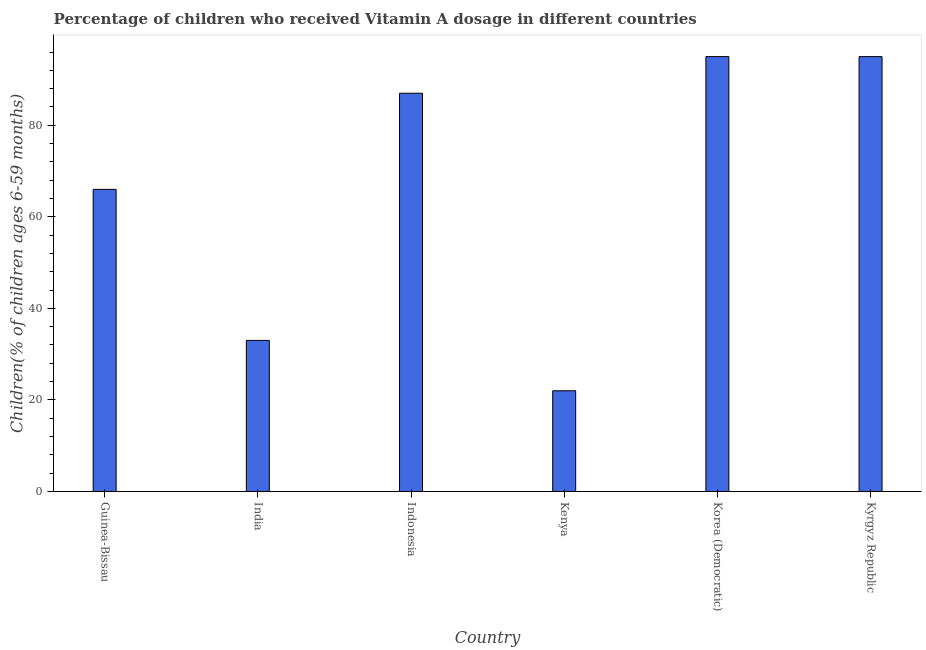Does the graph contain any zero values?
Your response must be concise. No. What is the title of the graph?
Your response must be concise. Percentage of children who received Vitamin A dosage in different countries. What is the label or title of the X-axis?
Offer a very short reply. Country. What is the label or title of the Y-axis?
Your answer should be compact. Children(% of children ages 6-59 months). What is the vitamin a supplementation coverage rate in Guinea-Bissau?
Offer a terse response. 66. Across all countries, what is the minimum vitamin a supplementation coverage rate?
Provide a succinct answer. 22. In which country was the vitamin a supplementation coverage rate maximum?
Your answer should be very brief. Korea (Democratic). In which country was the vitamin a supplementation coverage rate minimum?
Your answer should be compact. Kenya. What is the sum of the vitamin a supplementation coverage rate?
Give a very brief answer. 398. What is the difference between the vitamin a supplementation coverage rate in India and Korea (Democratic)?
Provide a short and direct response. -62. What is the average vitamin a supplementation coverage rate per country?
Ensure brevity in your answer.  66.33. What is the median vitamin a supplementation coverage rate?
Make the answer very short. 76.5. Is the vitamin a supplementation coverage rate in Indonesia less than that in Kenya?
Provide a succinct answer. No. Is the difference between the vitamin a supplementation coverage rate in Korea (Democratic) and Kyrgyz Republic greater than the difference between any two countries?
Make the answer very short. No. What is the difference between two consecutive major ticks on the Y-axis?
Offer a terse response. 20. What is the Children(% of children ages 6-59 months) of Guinea-Bissau?
Ensure brevity in your answer.  66. What is the Children(% of children ages 6-59 months) in Indonesia?
Make the answer very short. 87. What is the Children(% of children ages 6-59 months) of Korea (Democratic)?
Make the answer very short. 95. What is the Children(% of children ages 6-59 months) of Kyrgyz Republic?
Offer a terse response. 95. What is the difference between the Children(% of children ages 6-59 months) in Guinea-Bissau and India?
Your answer should be compact. 33. What is the difference between the Children(% of children ages 6-59 months) in Guinea-Bissau and Kenya?
Offer a terse response. 44. What is the difference between the Children(% of children ages 6-59 months) in Guinea-Bissau and Korea (Democratic)?
Your answer should be compact. -29. What is the difference between the Children(% of children ages 6-59 months) in Guinea-Bissau and Kyrgyz Republic?
Provide a succinct answer. -29. What is the difference between the Children(% of children ages 6-59 months) in India and Indonesia?
Your answer should be compact. -54. What is the difference between the Children(% of children ages 6-59 months) in India and Kenya?
Offer a very short reply. 11. What is the difference between the Children(% of children ages 6-59 months) in India and Korea (Democratic)?
Provide a short and direct response. -62. What is the difference between the Children(% of children ages 6-59 months) in India and Kyrgyz Republic?
Offer a very short reply. -62. What is the difference between the Children(% of children ages 6-59 months) in Indonesia and Kenya?
Provide a succinct answer. 65. What is the difference between the Children(% of children ages 6-59 months) in Indonesia and Kyrgyz Republic?
Your answer should be very brief. -8. What is the difference between the Children(% of children ages 6-59 months) in Kenya and Korea (Democratic)?
Provide a short and direct response. -73. What is the difference between the Children(% of children ages 6-59 months) in Kenya and Kyrgyz Republic?
Provide a short and direct response. -73. What is the ratio of the Children(% of children ages 6-59 months) in Guinea-Bissau to that in Indonesia?
Offer a very short reply. 0.76. What is the ratio of the Children(% of children ages 6-59 months) in Guinea-Bissau to that in Kenya?
Offer a very short reply. 3. What is the ratio of the Children(% of children ages 6-59 months) in Guinea-Bissau to that in Korea (Democratic)?
Provide a short and direct response. 0.69. What is the ratio of the Children(% of children ages 6-59 months) in Guinea-Bissau to that in Kyrgyz Republic?
Your response must be concise. 0.69. What is the ratio of the Children(% of children ages 6-59 months) in India to that in Indonesia?
Provide a short and direct response. 0.38. What is the ratio of the Children(% of children ages 6-59 months) in India to that in Korea (Democratic)?
Your answer should be compact. 0.35. What is the ratio of the Children(% of children ages 6-59 months) in India to that in Kyrgyz Republic?
Your answer should be very brief. 0.35. What is the ratio of the Children(% of children ages 6-59 months) in Indonesia to that in Kenya?
Offer a very short reply. 3.96. What is the ratio of the Children(% of children ages 6-59 months) in Indonesia to that in Korea (Democratic)?
Ensure brevity in your answer.  0.92. What is the ratio of the Children(% of children ages 6-59 months) in Indonesia to that in Kyrgyz Republic?
Ensure brevity in your answer.  0.92. What is the ratio of the Children(% of children ages 6-59 months) in Kenya to that in Korea (Democratic)?
Provide a short and direct response. 0.23. What is the ratio of the Children(% of children ages 6-59 months) in Kenya to that in Kyrgyz Republic?
Provide a succinct answer. 0.23. What is the ratio of the Children(% of children ages 6-59 months) in Korea (Democratic) to that in Kyrgyz Republic?
Provide a succinct answer. 1. 